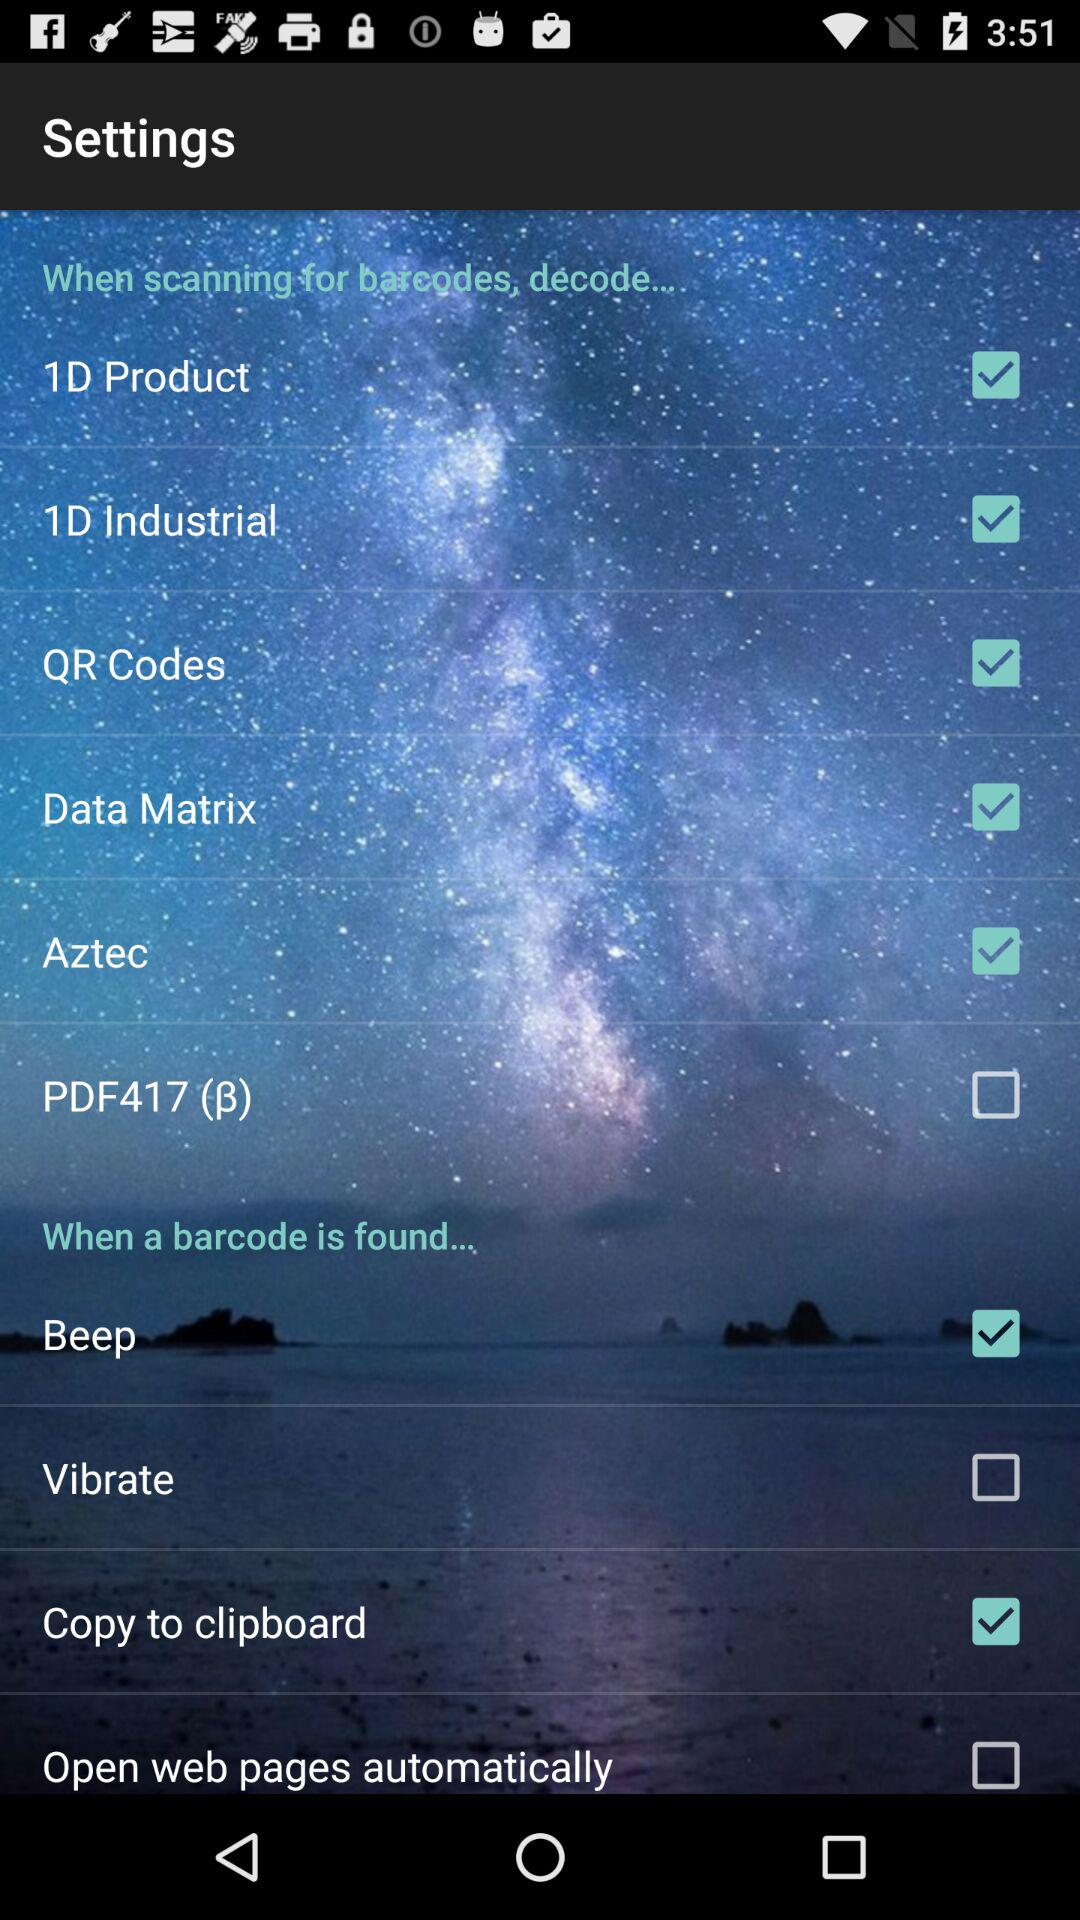How many actions can I take when a barcode is found?
Answer the question using a single word or phrase. 4 